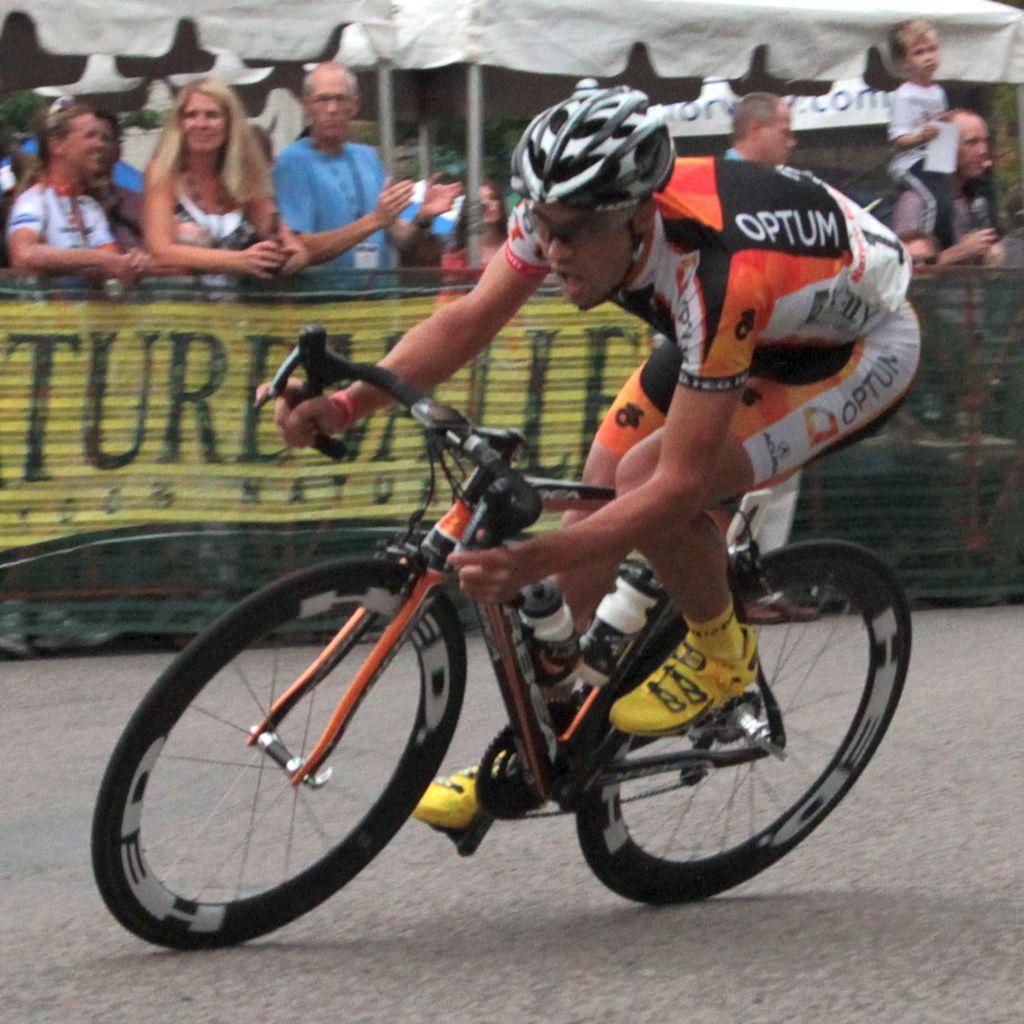Can you describe this image briefly? The person wearing orange dress is riding a bicycle and there are audience standing beside him. 